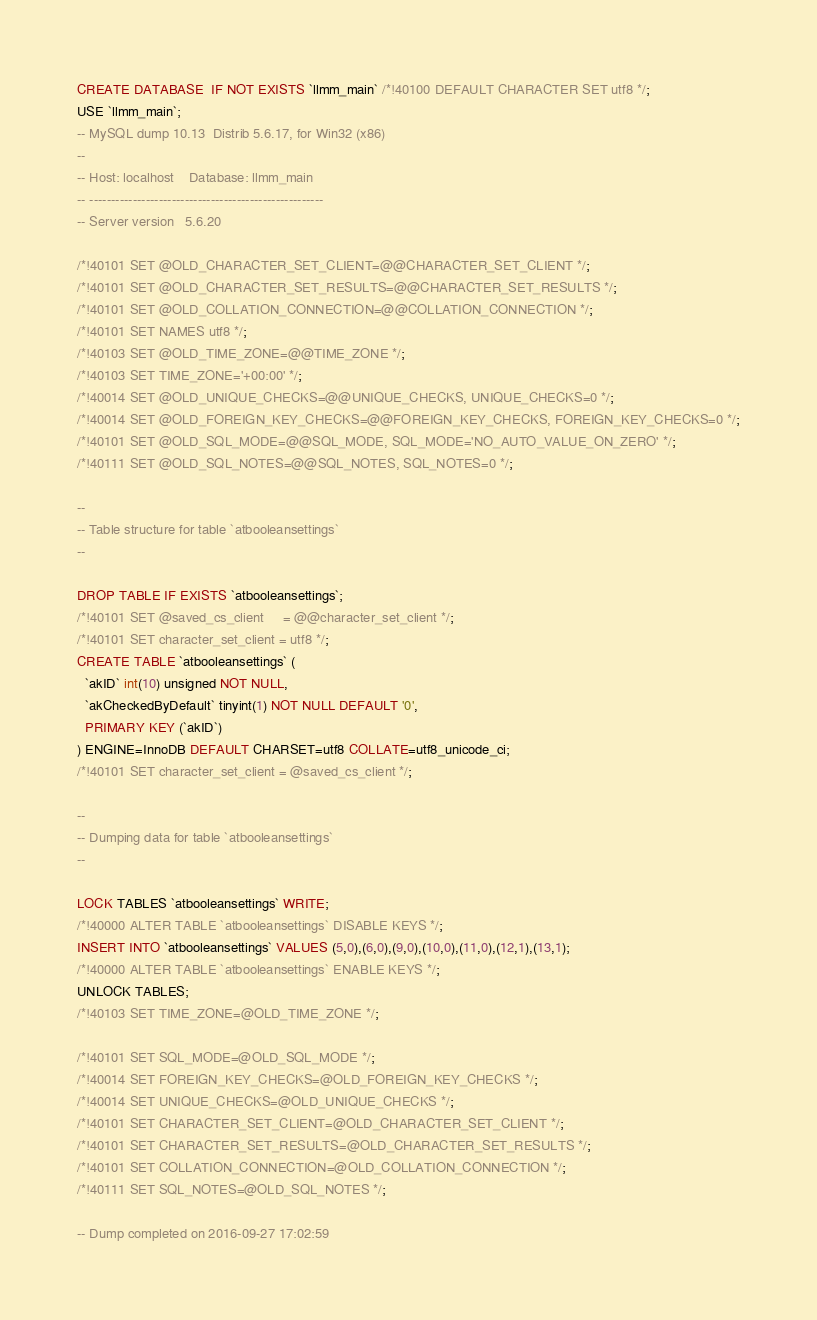Convert code to text. <code><loc_0><loc_0><loc_500><loc_500><_SQL_>CREATE DATABASE  IF NOT EXISTS `llmm_main` /*!40100 DEFAULT CHARACTER SET utf8 */;
USE `llmm_main`;
-- MySQL dump 10.13  Distrib 5.6.17, for Win32 (x86)
--
-- Host: localhost    Database: llmm_main
-- ------------------------------------------------------
-- Server version	5.6.20

/*!40101 SET @OLD_CHARACTER_SET_CLIENT=@@CHARACTER_SET_CLIENT */;
/*!40101 SET @OLD_CHARACTER_SET_RESULTS=@@CHARACTER_SET_RESULTS */;
/*!40101 SET @OLD_COLLATION_CONNECTION=@@COLLATION_CONNECTION */;
/*!40101 SET NAMES utf8 */;
/*!40103 SET @OLD_TIME_ZONE=@@TIME_ZONE */;
/*!40103 SET TIME_ZONE='+00:00' */;
/*!40014 SET @OLD_UNIQUE_CHECKS=@@UNIQUE_CHECKS, UNIQUE_CHECKS=0 */;
/*!40014 SET @OLD_FOREIGN_KEY_CHECKS=@@FOREIGN_KEY_CHECKS, FOREIGN_KEY_CHECKS=0 */;
/*!40101 SET @OLD_SQL_MODE=@@SQL_MODE, SQL_MODE='NO_AUTO_VALUE_ON_ZERO' */;
/*!40111 SET @OLD_SQL_NOTES=@@SQL_NOTES, SQL_NOTES=0 */;

--
-- Table structure for table `atbooleansettings`
--

DROP TABLE IF EXISTS `atbooleansettings`;
/*!40101 SET @saved_cs_client     = @@character_set_client */;
/*!40101 SET character_set_client = utf8 */;
CREATE TABLE `atbooleansettings` (
  `akID` int(10) unsigned NOT NULL,
  `akCheckedByDefault` tinyint(1) NOT NULL DEFAULT '0',
  PRIMARY KEY (`akID`)
) ENGINE=InnoDB DEFAULT CHARSET=utf8 COLLATE=utf8_unicode_ci;
/*!40101 SET character_set_client = @saved_cs_client */;

--
-- Dumping data for table `atbooleansettings`
--

LOCK TABLES `atbooleansettings` WRITE;
/*!40000 ALTER TABLE `atbooleansettings` DISABLE KEYS */;
INSERT INTO `atbooleansettings` VALUES (5,0),(6,0),(9,0),(10,0),(11,0),(12,1),(13,1);
/*!40000 ALTER TABLE `atbooleansettings` ENABLE KEYS */;
UNLOCK TABLES;
/*!40103 SET TIME_ZONE=@OLD_TIME_ZONE */;

/*!40101 SET SQL_MODE=@OLD_SQL_MODE */;
/*!40014 SET FOREIGN_KEY_CHECKS=@OLD_FOREIGN_KEY_CHECKS */;
/*!40014 SET UNIQUE_CHECKS=@OLD_UNIQUE_CHECKS */;
/*!40101 SET CHARACTER_SET_CLIENT=@OLD_CHARACTER_SET_CLIENT */;
/*!40101 SET CHARACTER_SET_RESULTS=@OLD_CHARACTER_SET_RESULTS */;
/*!40101 SET COLLATION_CONNECTION=@OLD_COLLATION_CONNECTION */;
/*!40111 SET SQL_NOTES=@OLD_SQL_NOTES */;

-- Dump completed on 2016-09-27 17:02:59
</code> 